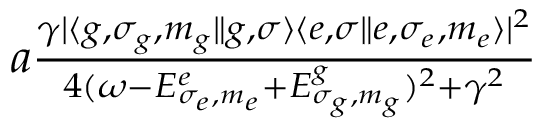Convert formula to latex. <formula><loc_0><loc_0><loc_500><loc_500>\begin{array} { r } { a \frac { \gamma | \langle g , \sigma _ { g } , m _ { g } \| { g , \sigma } \rangle \langle { e , \sigma } \| e , \sigma _ { e } , m _ { e } \rangle | ^ { 2 } } { 4 ( \omega - E _ { \sigma _ { e } , m _ { e } } ^ { e } + E _ { \sigma _ { g } , m _ { g } } ^ { g } ) ^ { 2 } + \gamma ^ { 2 } } } \end{array}</formula> 